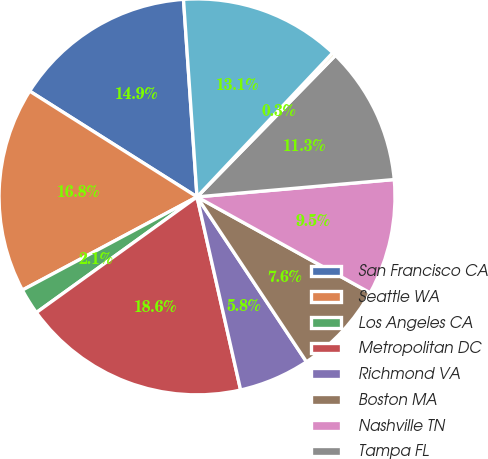<chart> <loc_0><loc_0><loc_500><loc_500><pie_chart><fcel>San Francisco CA<fcel>Seattle WA<fcel>Los Angeles CA<fcel>Metropolitan DC<fcel>Richmond VA<fcel>Boston MA<fcel>Nashville TN<fcel>Tampa FL<fcel>Other Florida<fcel>Dallas TX<nl><fcel>14.94%<fcel>16.77%<fcel>2.13%<fcel>18.6%<fcel>5.79%<fcel>7.62%<fcel>9.45%<fcel>11.28%<fcel>0.3%<fcel>13.11%<nl></chart> 